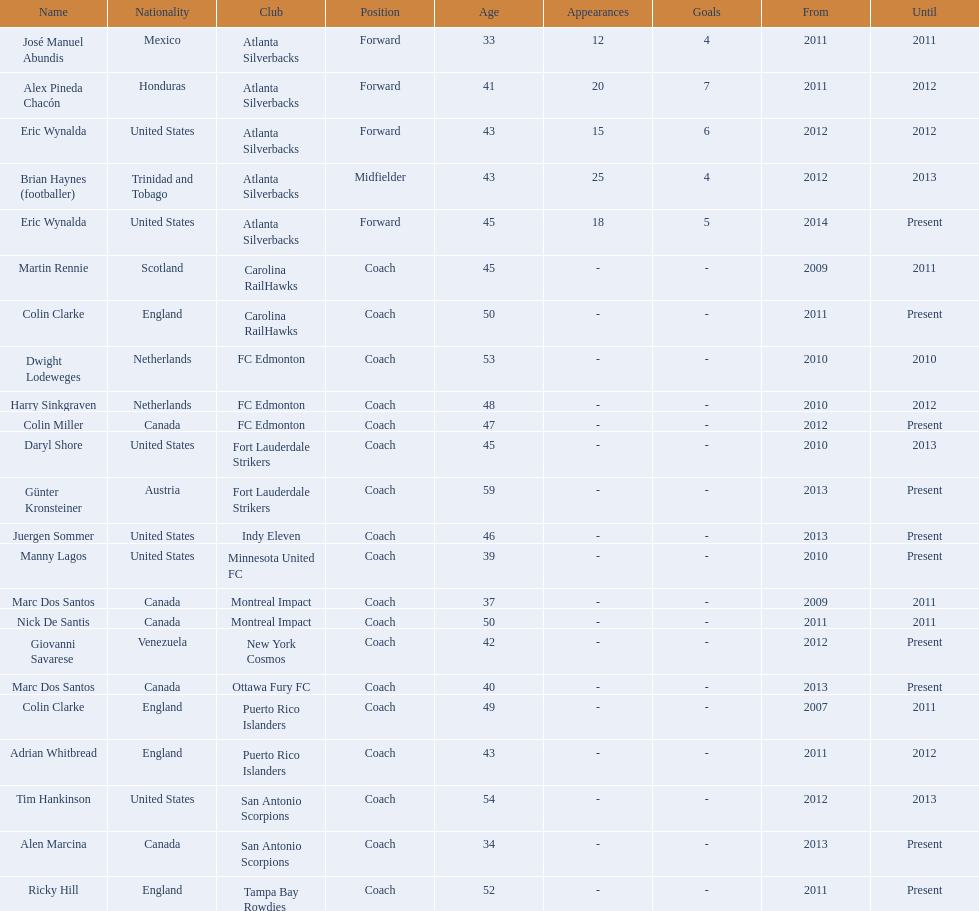What year did marc dos santos start as coach? 2009. Besides marc dos santos, what other coach started in 2009? Martin Rennie. 